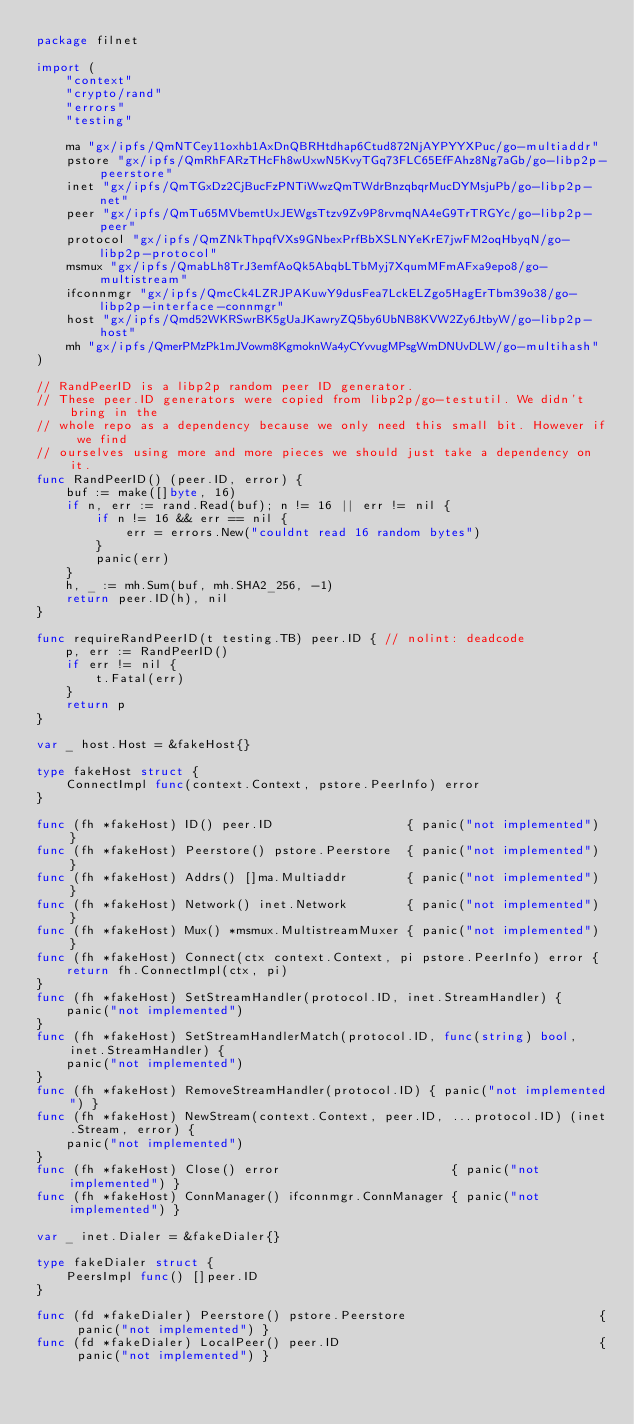<code> <loc_0><loc_0><loc_500><loc_500><_Go_>package filnet

import (
	"context"
	"crypto/rand"
	"errors"
	"testing"

	ma "gx/ipfs/QmNTCey11oxhb1AxDnQBRHtdhap6Ctud872NjAYPYYXPuc/go-multiaddr"
	pstore "gx/ipfs/QmRhFARzTHcFh8wUxwN5KvyTGq73FLC65EfFAhz8Ng7aGb/go-libp2p-peerstore"
	inet "gx/ipfs/QmTGxDz2CjBucFzPNTiWwzQmTWdrBnzqbqrMucDYMsjuPb/go-libp2p-net"
	peer "gx/ipfs/QmTu65MVbemtUxJEWgsTtzv9Zv9P8rvmqNA4eG9TrTRGYc/go-libp2p-peer"
	protocol "gx/ipfs/QmZNkThpqfVXs9GNbexPrfBbXSLNYeKrE7jwFM2oqHbyqN/go-libp2p-protocol"
	msmux "gx/ipfs/QmabLh8TrJ3emfAoQk5AbqbLTbMyj7XqumMFmAFxa9epo8/go-multistream"
	ifconnmgr "gx/ipfs/QmcCk4LZRJPAKuwY9dusFea7LckELZgo5HagErTbm39o38/go-libp2p-interface-connmgr"
	host "gx/ipfs/Qmd52WKRSwrBK5gUaJKawryZQ5by6UbNB8KVW2Zy6JtbyW/go-libp2p-host"
	mh "gx/ipfs/QmerPMzPk1mJVowm8KgmoknWa4yCYvvugMPsgWmDNUvDLW/go-multihash"
)

// RandPeerID is a libp2p random peer ID generator.
// These peer.ID generators were copied from libp2p/go-testutil. We didn't bring in the
// whole repo as a dependency because we only need this small bit. However if we find
// ourselves using more and more pieces we should just take a dependency on it.
func RandPeerID() (peer.ID, error) {
	buf := make([]byte, 16)
	if n, err := rand.Read(buf); n != 16 || err != nil {
		if n != 16 && err == nil {
			err = errors.New("couldnt read 16 random bytes")
		}
		panic(err)
	}
	h, _ := mh.Sum(buf, mh.SHA2_256, -1)
	return peer.ID(h), nil
}

func requireRandPeerID(t testing.TB) peer.ID { // nolint: deadcode
	p, err := RandPeerID()
	if err != nil {
		t.Fatal(err)
	}
	return p
}

var _ host.Host = &fakeHost{}

type fakeHost struct {
	ConnectImpl func(context.Context, pstore.PeerInfo) error
}

func (fh *fakeHost) ID() peer.ID                  { panic("not implemented") }
func (fh *fakeHost) Peerstore() pstore.Peerstore  { panic("not implemented") }
func (fh *fakeHost) Addrs() []ma.Multiaddr        { panic("not implemented") }
func (fh *fakeHost) Network() inet.Network        { panic("not implemented") }
func (fh *fakeHost) Mux() *msmux.MultistreamMuxer { panic("not implemented") }
func (fh *fakeHost) Connect(ctx context.Context, pi pstore.PeerInfo) error {
	return fh.ConnectImpl(ctx, pi)
}
func (fh *fakeHost) SetStreamHandler(protocol.ID, inet.StreamHandler) {
	panic("not implemented")
}
func (fh *fakeHost) SetStreamHandlerMatch(protocol.ID, func(string) bool, inet.StreamHandler) {
	panic("not implemented")
}
func (fh *fakeHost) RemoveStreamHandler(protocol.ID) { panic("not implemented") }
func (fh *fakeHost) NewStream(context.Context, peer.ID, ...protocol.ID) (inet.Stream, error) {
	panic("not implemented")
}
func (fh *fakeHost) Close() error                       { panic("not implemented") }
func (fh *fakeHost) ConnManager() ifconnmgr.ConnManager { panic("not implemented") }

var _ inet.Dialer = &fakeDialer{}

type fakeDialer struct {
	PeersImpl func() []peer.ID
}

func (fd *fakeDialer) Peerstore() pstore.Peerstore                          { panic("not implemented") }
func (fd *fakeDialer) LocalPeer() peer.ID                                   { panic("not implemented") }</code> 